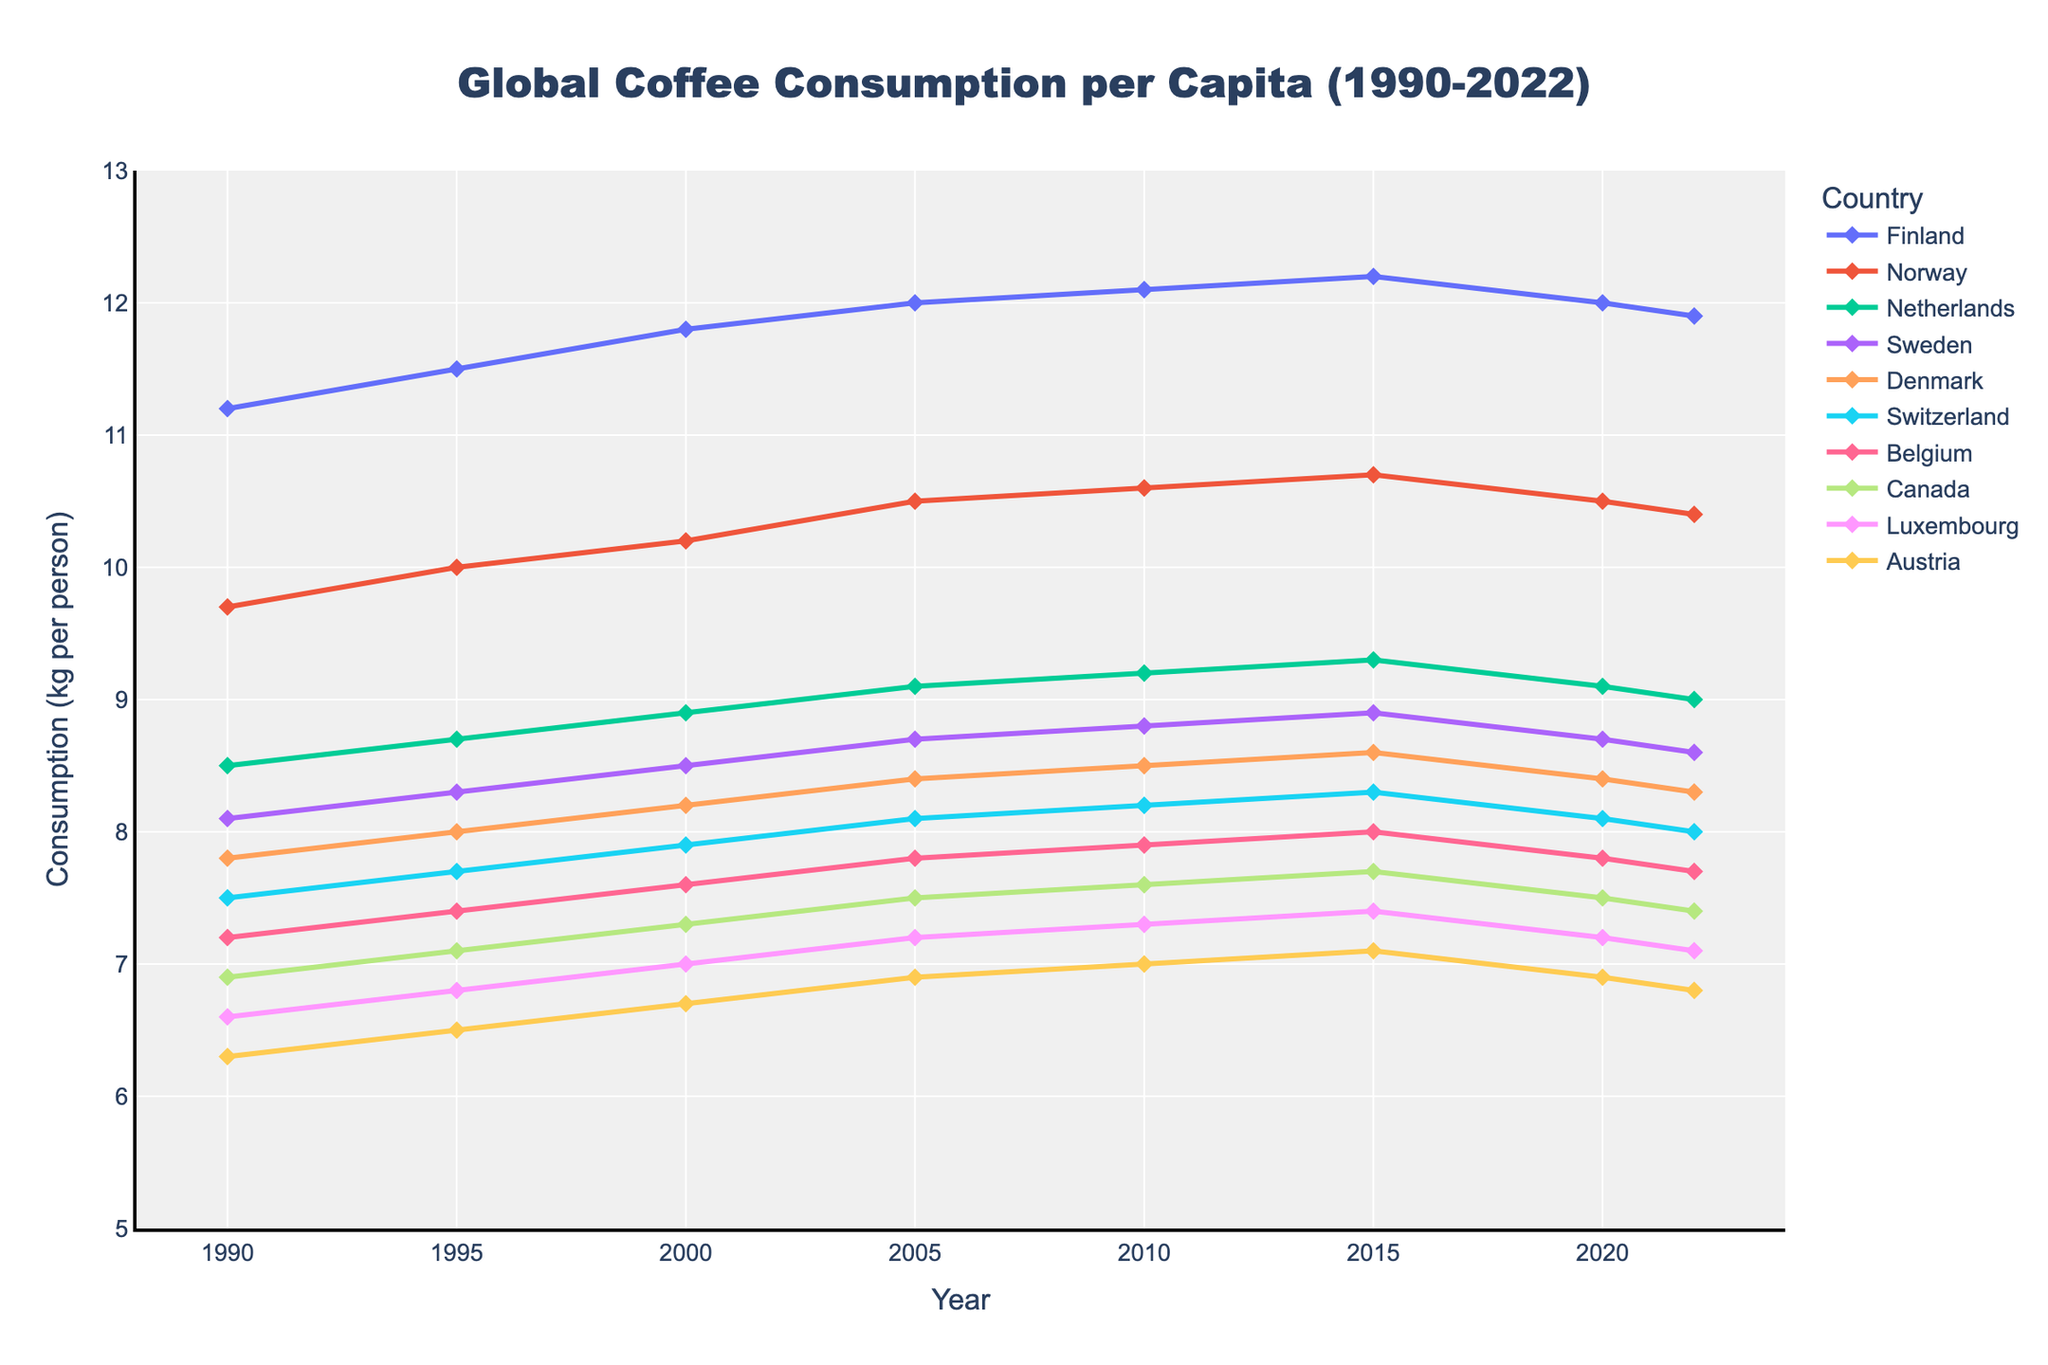What was the average coffee consumption per person in Finland between 1990 and 2022? First, find the annual values for Finland: 11.2, 11.5, 11.8, 12.0, 12.1, 12.2, 12.0, 11.9. Next, sum these values: 11.2 + 11.5 + 11.8 + 12.0 + 12.1 + 12.2 + 12.0 + 11.9 = 94.7. Finally, divide by the number of years (8): 94.7 / 8 = 11.84 kg per person
Answer: 11.84 Which country had the highest coffee consumption per capita in 2022? Look at the data for 2022 for each country: Finland (11.9), Norway (10.4), Netherlands (9.0), Sweden (8.6), Denmark (8.3), Switzerland (8.0), Belgium (7.7), Canada (7.4), Luxembourg (7.1), Austria (6.8). The highest value is 11.9, which corresponds to Finland
Answer: Finland How much did coffee consumption per person in Norway increase from 1990 to 2022? First, find Norway's coffee consumption in 1990 (9.7 kg) and in 2022 (10.4 kg). Then, calculate the difference: 10.4 - 9.7 = 0.7 kg
Answer: 0.7 kg Which country showed the least change in coffee consumption per capita from 1990 to 2022? Calculate the difference for each country between 1990 and 2022. Finland: 11.9 - 11.2 = 0.7, Norway: 10.4 - 9.7 = 0.7, Netherlands: 9.0 - 8.5 = 0.5, Sweden: 8.6 - 8.1 = 0.5, Denmark: 8.3 - 7.8 = 0.5, Switzerland: 8.0 - 7.5 = 0.5, Belgium: 7.7 - 7.2 = 0.5, Canada: 7.4 - 6.9 = 0.5, Luxembourg: 7.1 - 6.6 = 0.5, Austria: 6.8 - 6.3 = 0.5. All countries except Finland and Norway showed the same change of 0.5 kg.
Answer: Netherlands, Sweden, Denmark, Switzerland, Belgium, Canada, Luxembourg, Austria Rank the top three countries in descending order of coffee consumption per capita in 2015. Look at the coffee consumption data for 2015: Finland (12.2), Norway (10.7), Netherlands (9.3), Sweden (8.9), Denmark (8.6), Switzerland (8.3), Belgium (8.0), Canada (7.7), Luxembourg (7.4), Austria (7.1). The top three countries are Finland (12.2), Norway (10.7), and Netherlands (9.3).
Answer: Finland, Norway, Netherlands Between which two consecutive years did Canada see the highest increase in coffee consumption per capita? Calculate the change in consumption from one period to the next for Canada: 1990-1995 (7.1 - 6.9 = 0.2), 1995-2000 (7.3 - 7.1 = 0.2), 2000-2005 (7.5 - 7.3 = 0.2), 2005-2010 (7.6 - 7.5 = 0.1), 2010-2015 (7.7 - 7.6 = 0.1), 2015-2020 (7.5 - 7.7 = -0.2), 2020-2022 (7.4 - 7.5 = -0.1). The highest increase is 0.2, occurring between 1990-1995, 1995-2000, and 2000-2005.
Answer: 1990-1995, 1995-2000, 2000-2005 Did any country experience a decrease in coffee consumption per capita from 2020 to 2022? Check the coffee consumption data for 2020 and 2022: Finland (12.0 to 11.9), Norway (10.5 to 10.4), Netherlands (9.1 to 9.0), Sweden (8.7 to 8.6), Denmark (8.4 to 8.3), Switzerland (8.1 to 8.0), Belgium (7.8 to 7.7), Canada (7.5 to 7.4), Luxembourg (7.2 to 7.1), Austria (6.9 to 6.8). All countries show a decrease in their coffee consumption from 2020 to 2022.
Answer: All countries By how much did Finland's coffee consumption per capita increase from 1990 to 2005? First, find Finland's coffee consumption in 1990 (11.2 kg) and in 2005 (12.0 kg). Then, calculate the difference: 12.0 - 11.2 = 0.8 kg.
Answer: 0.8 kg 